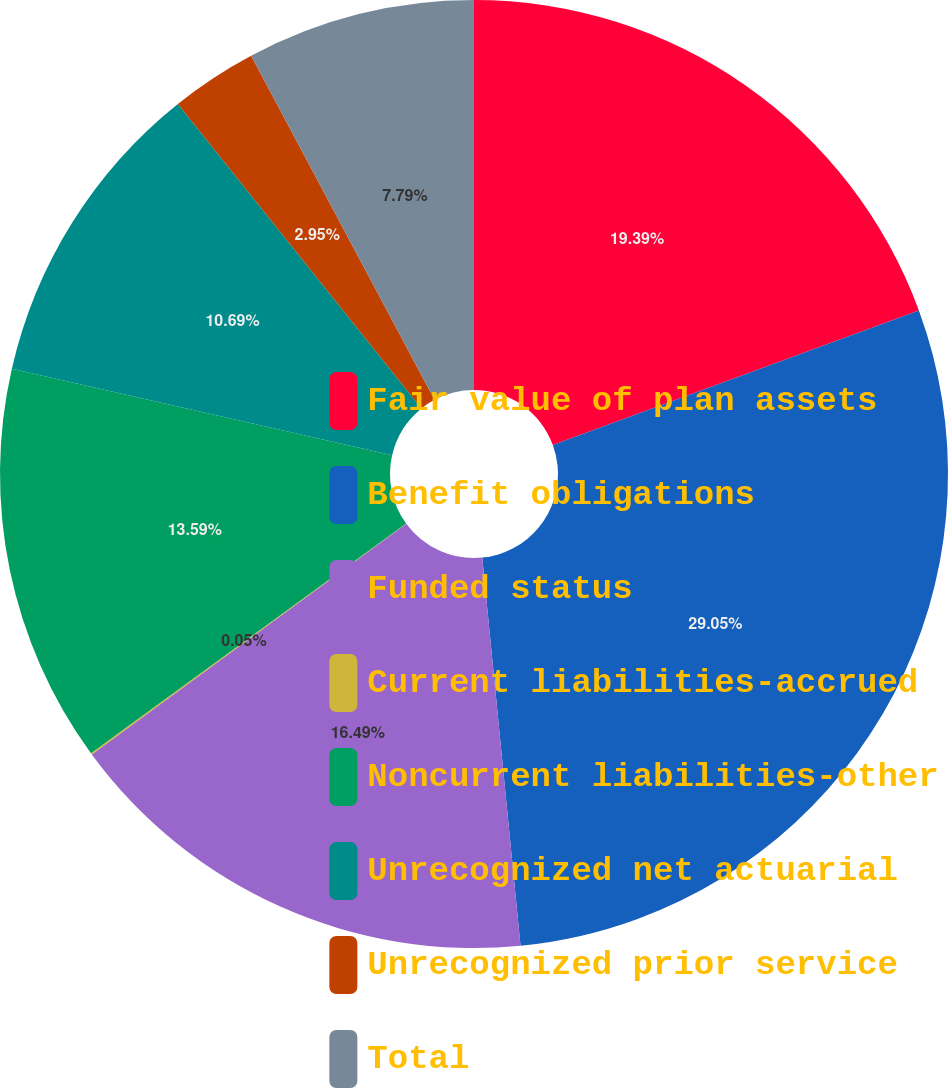Convert chart to OTSL. <chart><loc_0><loc_0><loc_500><loc_500><pie_chart><fcel>Fair value of plan assets<fcel>Benefit obligations<fcel>Funded status<fcel>Current liabilities-accrued<fcel>Noncurrent liabilities-other<fcel>Unrecognized net actuarial<fcel>Unrecognized prior service<fcel>Total<nl><fcel>19.39%<fcel>29.04%<fcel>16.49%<fcel>0.05%<fcel>13.59%<fcel>10.69%<fcel>2.95%<fcel>7.79%<nl></chart> 